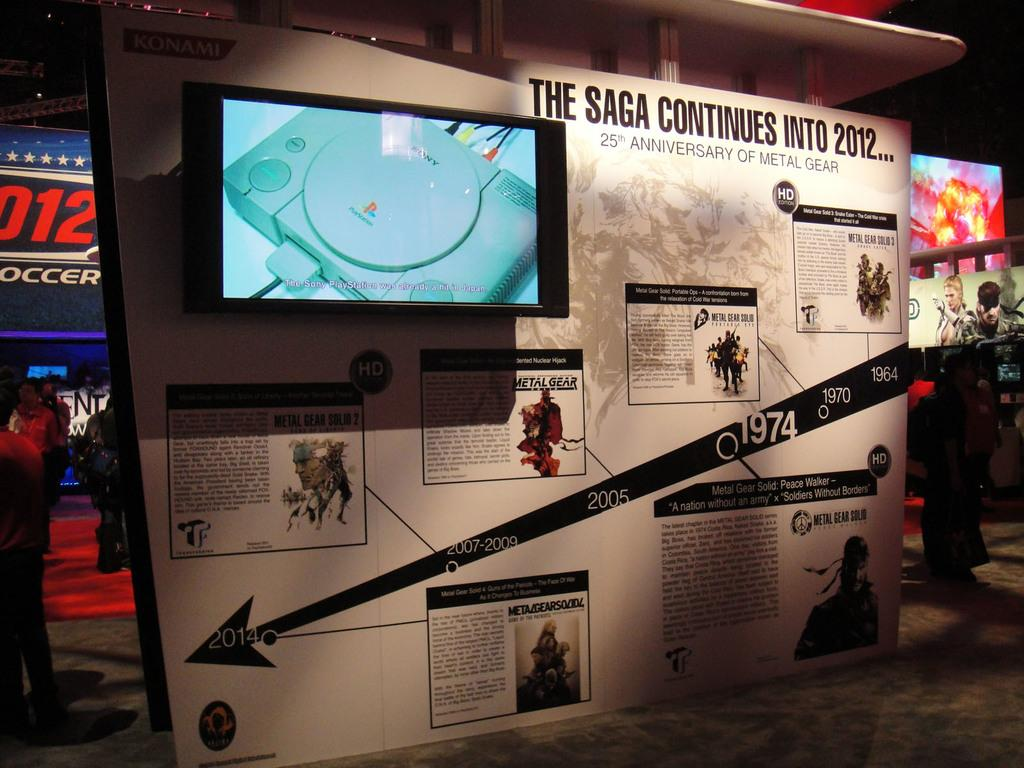<image>
Write a terse but informative summary of the picture. A timeline with a Playstation with the title the Saga Continues into 2012. 